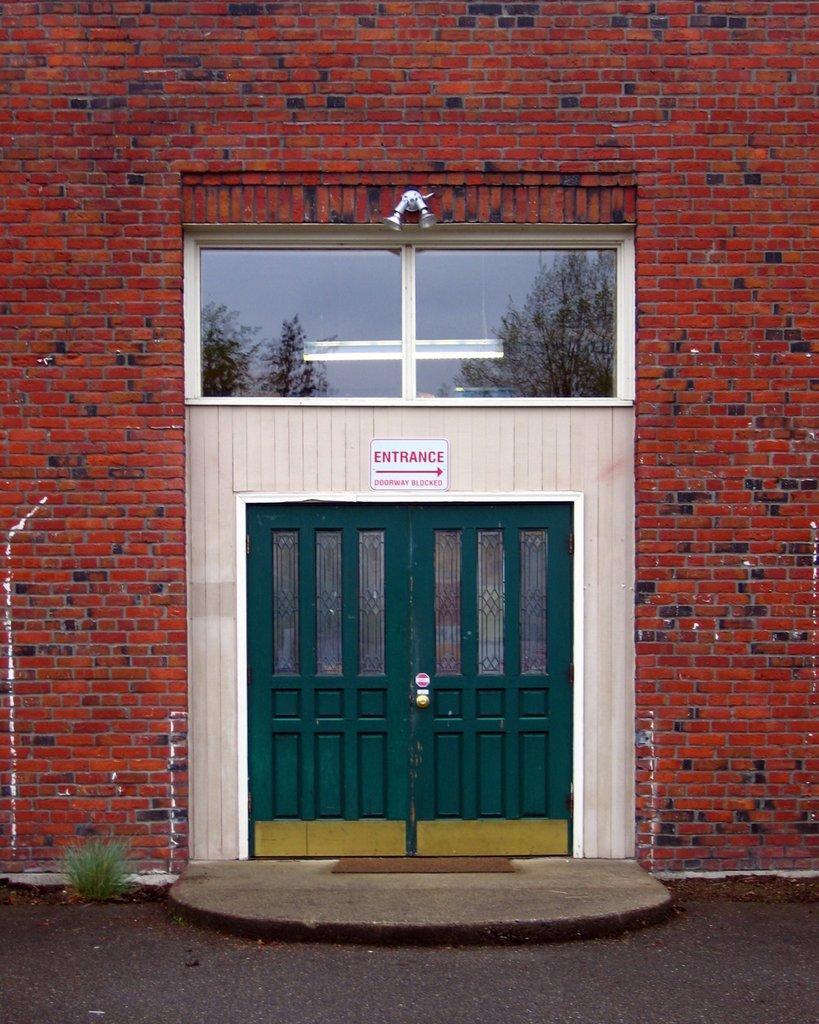In one or two sentences, can you explain what this image depicts? In this image, I can see a building with a glass window, entrance board and a door. At the bottom of the image, I can see a doormat in front of the door. On the left side of the image, I can see a grass. 